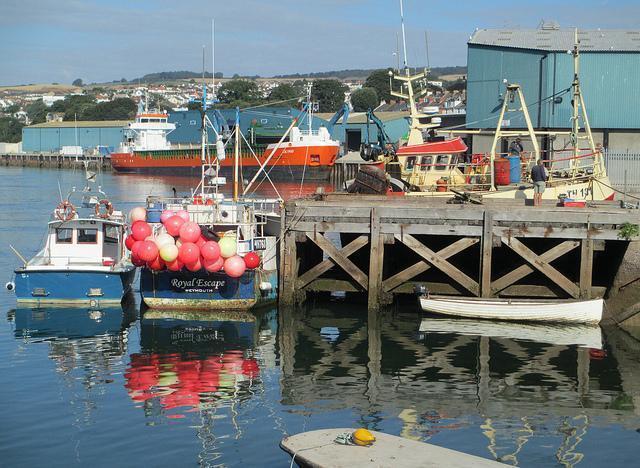Why are all those balloons in the boat?
Make your selection and explain in format: 'Answer: answer
Rationale: rationale.'
Options: Fell there, celebration, for sale, stolen. Answer: celebration.
Rationale: The balloons are for a celebration. 